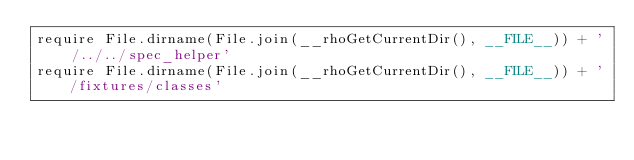Convert code to text. <code><loc_0><loc_0><loc_500><loc_500><_Ruby_>require File.dirname(File.join(__rhoGetCurrentDir(), __FILE__)) + '/../../spec_helper'
require File.dirname(File.join(__rhoGetCurrentDir(), __FILE__)) + '/fixtures/classes'
</code> 